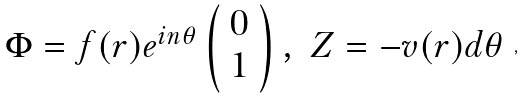<formula> <loc_0><loc_0><loc_500><loc_500>\begin{array} { c c } { { \Phi = f ( r ) e ^ { i n \theta } \left ( \begin{array} { c } { 0 } \\ { 1 } \end{array} \right ) , } } & { Z = - v ( r ) d \theta } \end{array} ,</formula> 